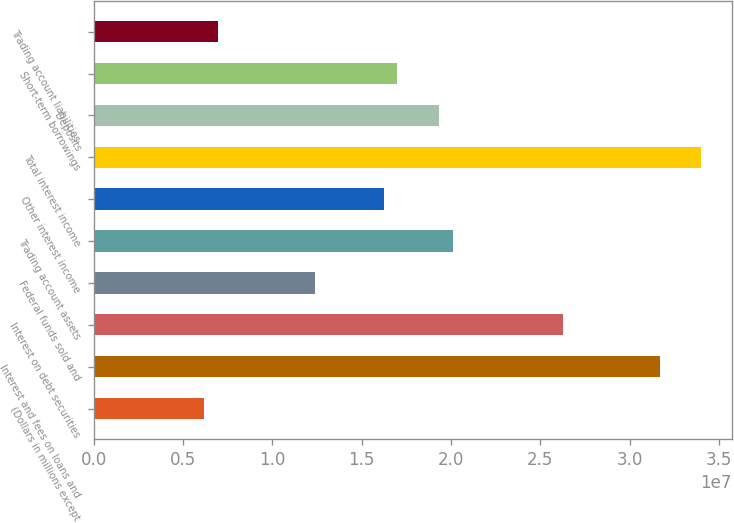<chart> <loc_0><loc_0><loc_500><loc_500><bar_chart><fcel>(Dollars in millions except<fcel>Interest and fees on loans and<fcel>Interest on debt securities<fcel>Federal funds sold and<fcel>Trading account assets<fcel>Other interest income<fcel>Total interest income<fcel>Deposits<fcel>Short-term borrowings<fcel>Trading account liabilities<nl><fcel>6.18286e+06<fcel>3.16871e+07<fcel>2.62771e+07<fcel>1.23657e+07<fcel>2.00943e+07<fcel>1.623e+07<fcel>3.40057e+07<fcel>1.93214e+07<fcel>1.70029e+07<fcel>6.95571e+06<nl></chart> 